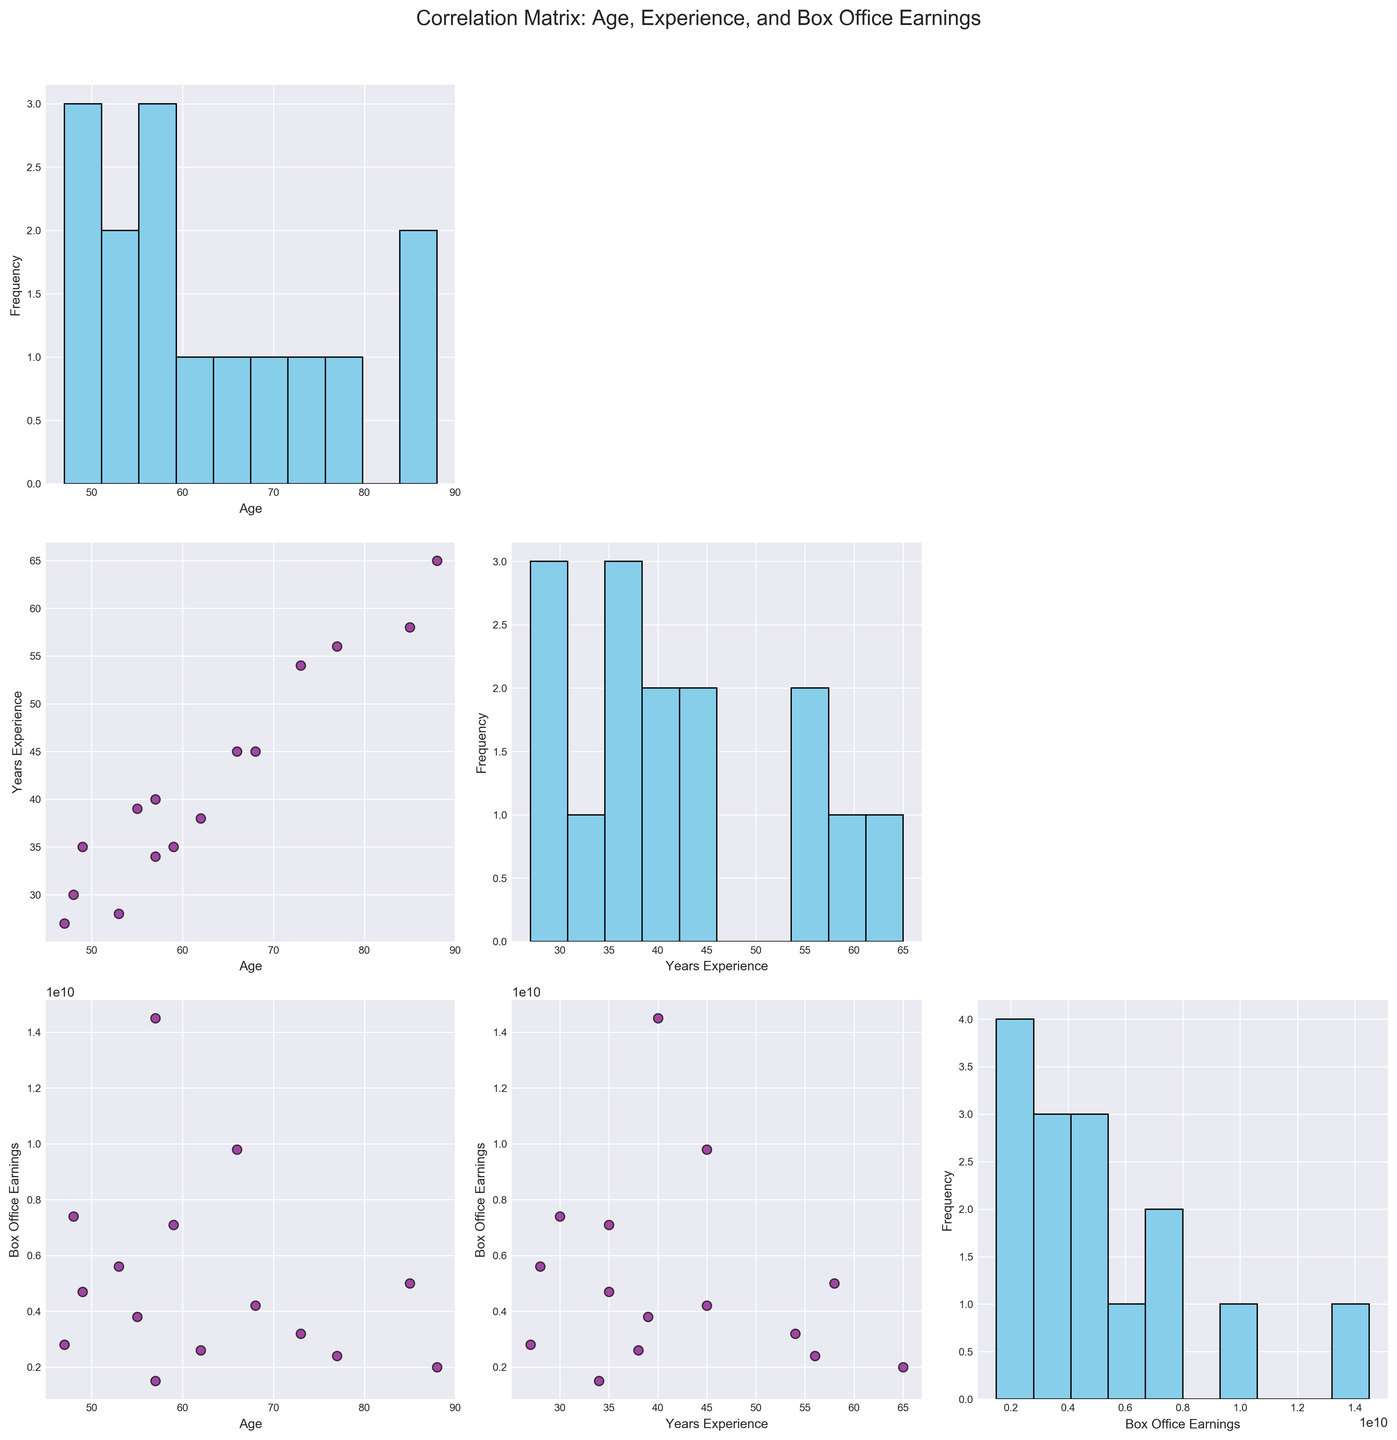What's the title of the figure? The title of the figure is located at the top and summarizes what the figure is about. Here, it reads: "Correlation Matrix: Age, Experience, and Box Office Earnings".
Answer: Correlation Matrix: Age, Experience, and Box Office Earnings How many variables are being analyzed in the figure? The figure displays a scatterplot matrix, and the analyzed variables are listed on the axes of the subplots. They are 'Age', 'Years Experience', and 'Box Office Earnings'.
Answer: 3 Which variable shows the highest frequency when plotted in a histogram? The histograms appear on the diagonal of the scatterplot matrix. By observing the height of the bars, 'Box Office Earnings' has a high bar count compared to the spread of the other variables.
Answer: Box Office Earnings What is the general trend observed between 'Years Experience' and 'Age'? By examining the scatterplot between 'Years Experience' and 'Age', we can see that as 'Age' increases, 'Years Experience' also increases. This indicates a positive correlation.
Answer: Positive correlation Between which two variables can you observe the strongest correlation? By looking at the scatterplots and the density of the points, the strongest linear relationship appears to be between 'Age' and 'Years Experience', as the points form a clearer straight-line pattern compared to other pairs of variables.
Answer: Age and Years Experience Is there any negative correlation visible between any pair of variables? Negative correlation would be indicated by a downward trend in the scatterplot. None of the scatterplots illustrate a consistent downward trend. All visible correlations are either positive or have no apparent trend.
Answer: No Which pair of variables shows the most scattered data points without a clear trend? Examining the scatterplot matrix, the scatterplot for 'Years Experience' and 'Box Office Earnings' appears to have the most scattered data points, indicating no clear trend or correlation.
Answer: Years Experience and Box Office Earnings How does 'Box Office Earnings' distribution compare to 'Age' distribution? By observing the histograms, 'Box Office Earnings' has a wider range and higher frequencies at certain intervals, whereas 'Age' has a more uniform distribution.
Answer: 'Box Office Earnings' has a wider range and higher frequencies at certain intervals Does a higher 'Years Experience' imply higher 'Box Office Earnings'? Looking at the scatterplot between 'Years Experience' and 'Box Office Earnings', there is no clear trend to suggest that higher 'Years Experience' correlates to higher 'Box Office Earnings'. The points are dispersed without a clear pattern.
Answer: No Which actor group seems to dominate in leading roles based on the scatterplot matrix? Even though individual actors are not identified in the scatterplot, the clusters give a hint. The higher 'Box Office Earnings' and significant spread in 'Age' and 'Years Experience' indicate that both older and experienced actors are dominating.
Answer: Older and experienced actors 